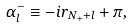<formula> <loc_0><loc_0><loc_500><loc_500>\alpha _ { l } ^ { - } \equiv - i r _ { N _ { + } + l } + \pi ,</formula> 